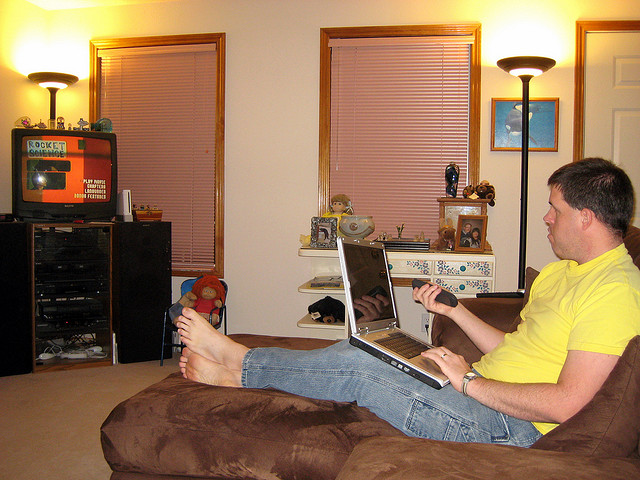Identify and read out the text in this image. ROCKET 